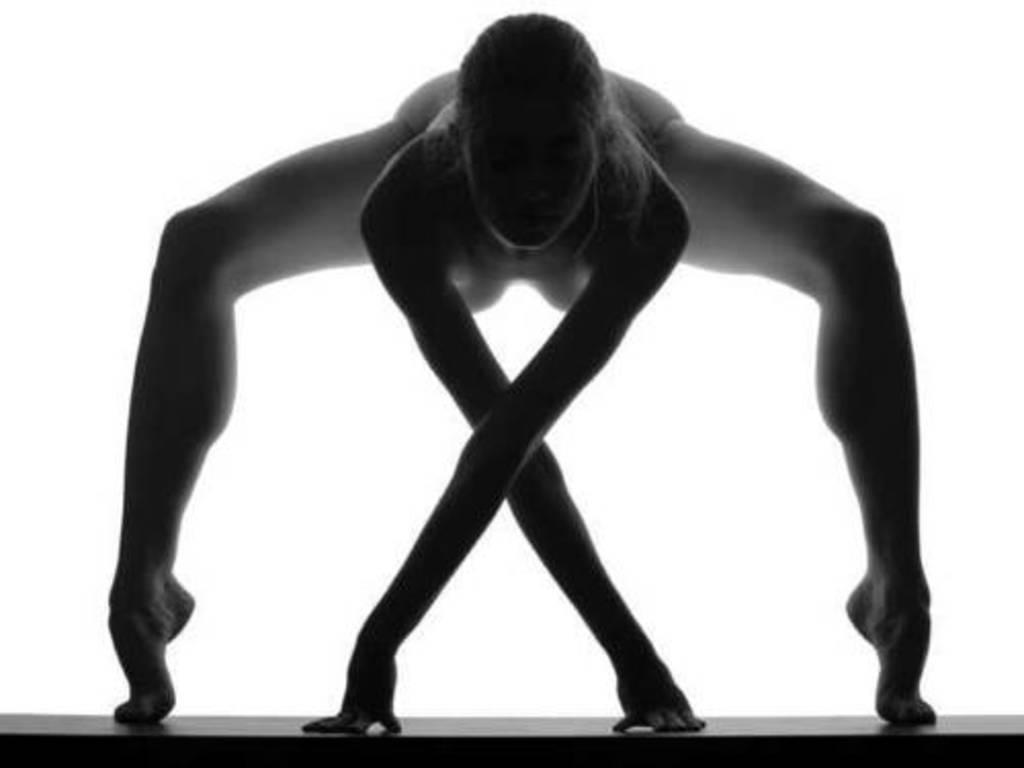Who is the main subject in the image? There is a woman in the image. What is the woman standing on? The woman is on a platform. What color is the background of the image? The background of the image is white. What type of winter clothing is the maid wearing in the image? There is no maid or winter clothing present in the image; it features a woman on a platform with a white background. What scientific experiment is being conducted in the image? There is no scientific experiment present in the image; it features a woman on a platform with a white background. 